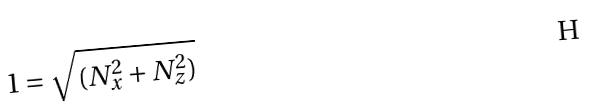Convert formula to latex. <formula><loc_0><loc_0><loc_500><loc_500>1 = \sqrt { ( N _ { x } ^ { 2 } + N _ { z } ^ { 2 } ) }</formula> 